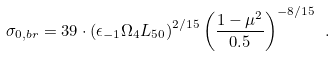Convert formula to latex. <formula><loc_0><loc_0><loc_500><loc_500>\sigma _ { 0 , b r } = 3 9 \cdot \left ( \epsilon _ { - 1 } \Omega _ { 4 } L _ { 5 0 } \right ) ^ { 2 / 1 5 } \left ( \frac { 1 - \mu ^ { 2 } } { 0 . 5 } \right ) ^ { - 8 / 1 5 } \ .</formula> 